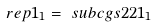<formula> <loc_0><loc_0><loc_500><loc_500>\ r e p { 1 } _ { 1 } & = \ s u b c g s { 2 } { 2 } { 1 _ { 1 } }</formula> 